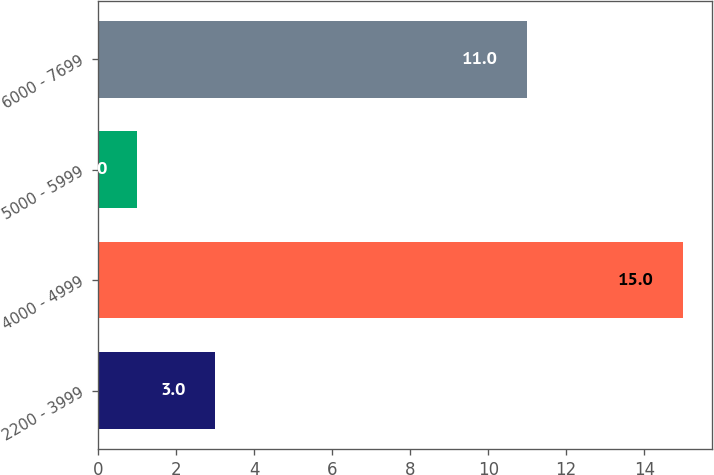Convert chart. <chart><loc_0><loc_0><loc_500><loc_500><bar_chart><fcel>2200 - 3999<fcel>4000 - 4999<fcel>5000 - 5999<fcel>6000 - 7699<nl><fcel>3<fcel>15<fcel>1<fcel>11<nl></chart> 